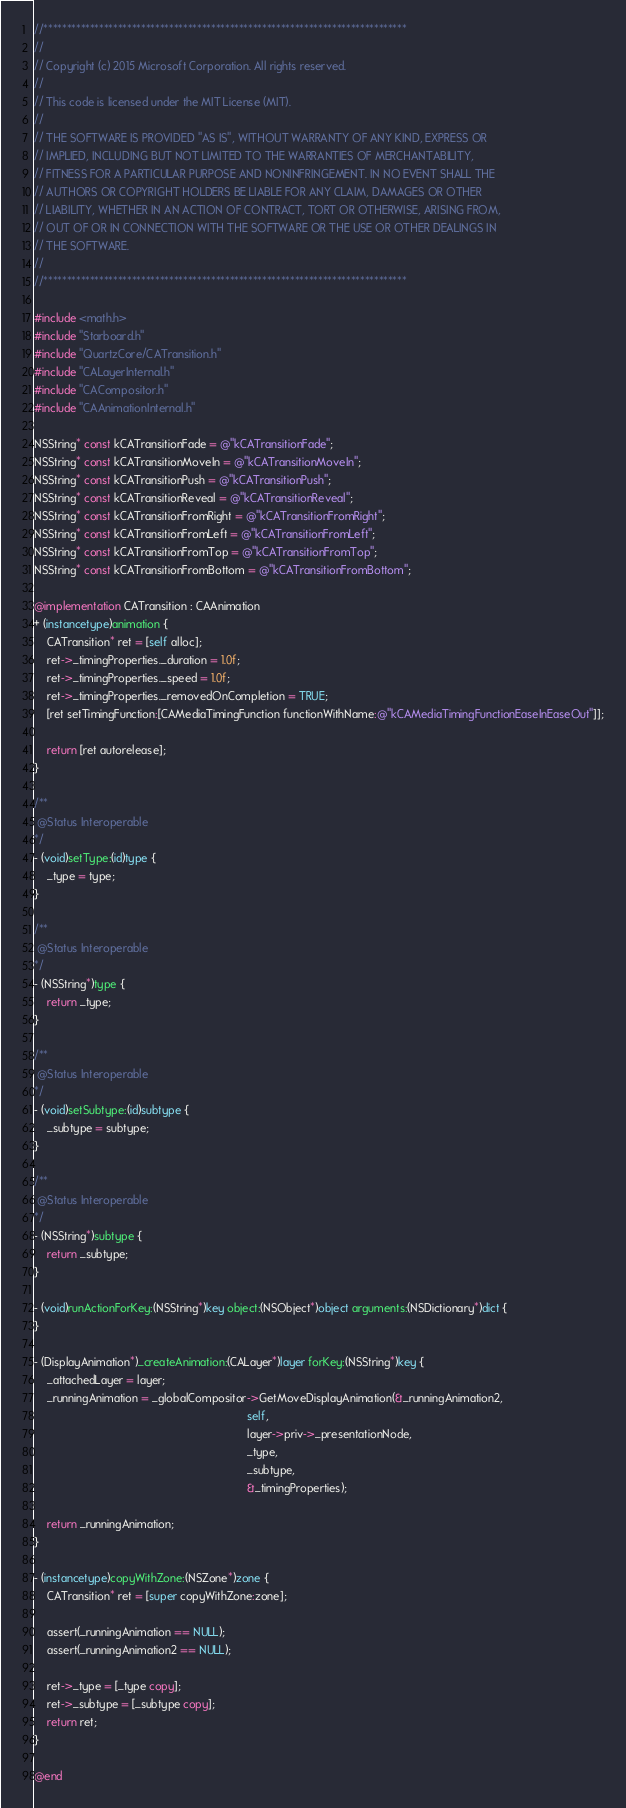Convert code to text. <code><loc_0><loc_0><loc_500><loc_500><_ObjectiveC_>//******************************************************************************
//
// Copyright (c) 2015 Microsoft Corporation. All rights reserved.
//
// This code is licensed under the MIT License (MIT).
//
// THE SOFTWARE IS PROVIDED "AS IS", WITHOUT WARRANTY OF ANY KIND, EXPRESS OR
// IMPLIED, INCLUDING BUT NOT LIMITED TO THE WARRANTIES OF MERCHANTABILITY,
// FITNESS FOR A PARTICULAR PURPOSE AND NONINFRINGEMENT. IN NO EVENT SHALL THE
// AUTHORS OR COPYRIGHT HOLDERS BE LIABLE FOR ANY CLAIM, DAMAGES OR OTHER
// LIABILITY, WHETHER IN AN ACTION OF CONTRACT, TORT OR OTHERWISE, ARISING FROM,
// OUT OF OR IN CONNECTION WITH THE SOFTWARE OR THE USE OR OTHER DEALINGS IN
// THE SOFTWARE.
//
//******************************************************************************

#include <math.h>
#include "Starboard.h"
#include "QuartzCore/CATransition.h"
#include "CALayerInternal.h"
#include "CACompositor.h"
#include "CAAnimationInternal.h"

NSString* const kCATransitionFade = @"kCATransitionFade";
NSString* const kCATransitionMoveIn = @"kCATransitionMoveIn";
NSString* const kCATransitionPush = @"kCATransitionPush";
NSString* const kCATransitionReveal = @"kCATransitionReveal";
NSString* const kCATransitionFromRight = @"kCATransitionFromRight";
NSString* const kCATransitionFromLeft = @"kCATransitionFromLeft";
NSString* const kCATransitionFromTop = @"kCATransitionFromTop";
NSString* const kCATransitionFromBottom = @"kCATransitionFromBottom";

@implementation CATransition : CAAnimation
+ (instancetype)animation {
    CATransition* ret = [self alloc];
    ret->_timingProperties._duration = 1.0f;
    ret->_timingProperties._speed = 1.0f;
    ret->_timingProperties._removedOnCompletion = TRUE;
    [ret setTimingFunction:[CAMediaTimingFunction functionWithName:@"kCAMediaTimingFunctionEaseInEaseOut"]];

    return [ret autorelease];
}

/**
 @Status Interoperable
*/
- (void)setType:(id)type {
    _type = type;
}

/**
 @Status Interoperable
*/
- (NSString*)type {
    return _type;
}

/**
 @Status Interoperable
*/
- (void)setSubtype:(id)subtype {
    _subtype = subtype;
}

/**
 @Status Interoperable
*/
- (NSString*)subtype {
    return _subtype;
}

- (void)runActionForKey:(NSString*)key object:(NSObject*)object arguments:(NSDictionary*)dict {
}

- (DisplayAnimation*)_createAnimation:(CALayer*)layer forKey:(NSString*)key {
    _attachedLayer = layer;
    _runningAnimation = _globalCompositor->GetMoveDisplayAnimation(&_runningAnimation2,
                                                                   self,
                                                                   layer->priv->_presentationNode,
                                                                   _type,
                                                                   _subtype,
                                                                   &_timingProperties);

    return _runningAnimation;
}

- (instancetype)copyWithZone:(NSZone*)zone {
    CATransition* ret = [super copyWithZone:zone];

    assert(_runningAnimation == NULL);
    assert(_runningAnimation2 == NULL);

    ret->_type = [_type copy];
    ret->_subtype = [_subtype copy];
    return ret;
}

@end
</code> 